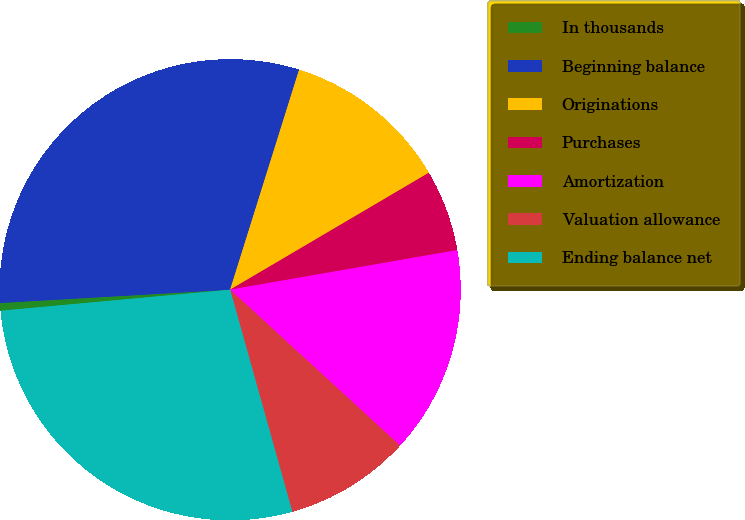Convert chart to OTSL. <chart><loc_0><loc_0><loc_500><loc_500><pie_chart><fcel>In thousands<fcel>Beginning balance<fcel>Originations<fcel>Purchases<fcel>Amortization<fcel>Valuation allowance<fcel>Ending balance net<nl><fcel>0.54%<fcel>30.75%<fcel>11.7%<fcel>5.72%<fcel>14.56%<fcel>8.84%<fcel>27.89%<nl></chart> 